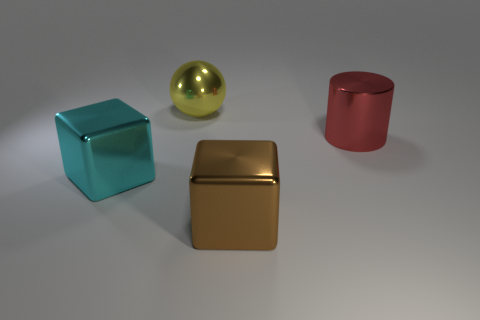The large sphere that is the same material as the large red object is what color? yellow 